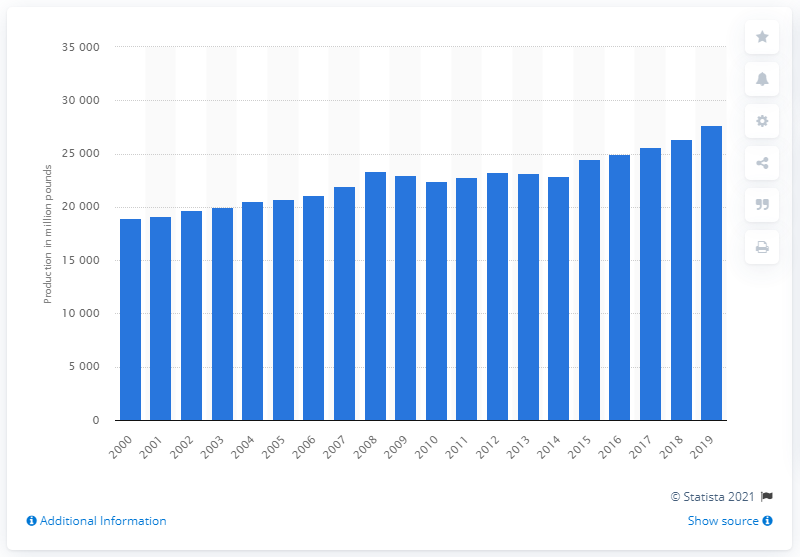Specify some key components in this picture. In 2019, approximately 276,510 metric tons of pork were produced in the United States. The last time pork was produced in the United States was in the year 2000. 